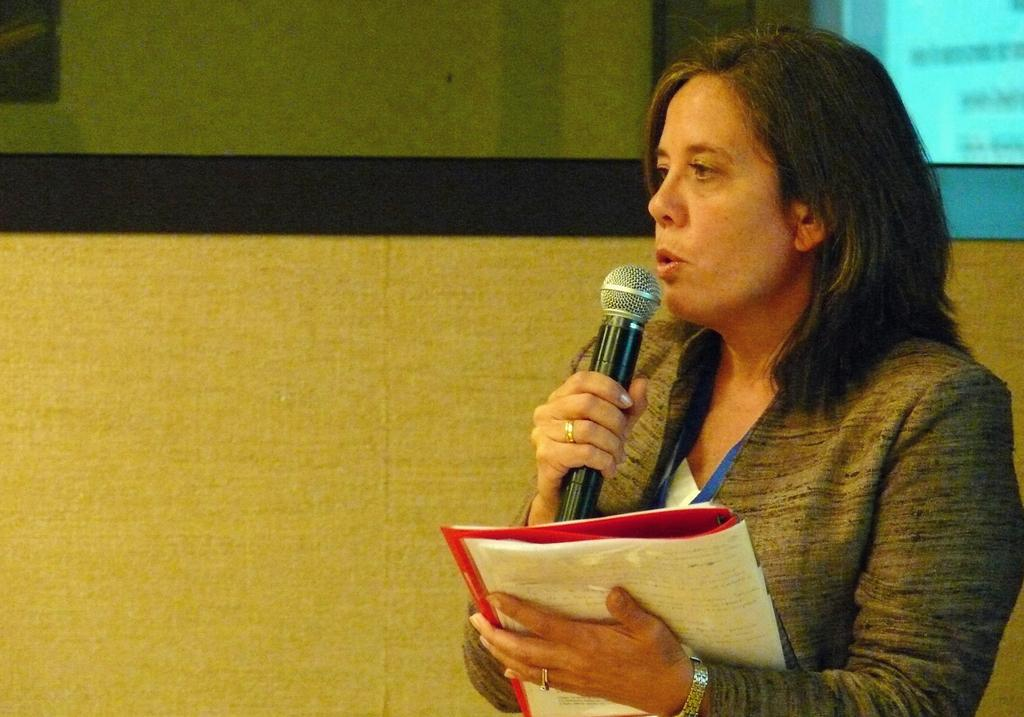Who is the main subject in the image? There is a woman in the image. What is the woman holding in her right hand? The woman is holding a mic in her right hand. What is the woman holding in her left hand? The woman is holding a book in her left hand. What is the woman doing in the image? The woman is delivering a speech. What is visible behind the woman? There is a screen behind the woman. What type of brass can be seen on the drawer in the image? There is no drawer or brass present in the image. What is the woman reading from in the image? The woman is not reading from anything in the image; she is delivering a speech while holding a book. 